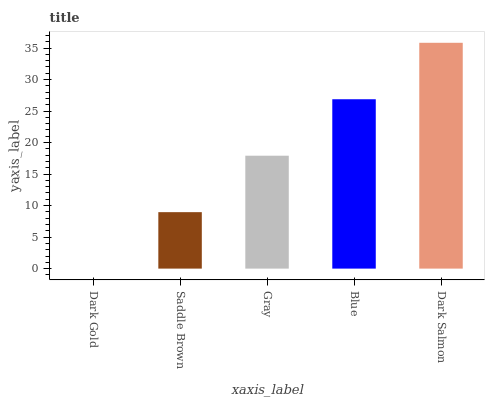Is Dark Gold the minimum?
Answer yes or no. Yes. Is Dark Salmon the maximum?
Answer yes or no. Yes. Is Saddle Brown the minimum?
Answer yes or no. No. Is Saddle Brown the maximum?
Answer yes or no. No. Is Saddle Brown greater than Dark Gold?
Answer yes or no. Yes. Is Dark Gold less than Saddle Brown?
Answer yes or no. Yes. Is Dark Gold greater than Saddle Brown?
Answer yes or no. No. Is Saddle Brown less than Dark Gold?
Answer yes or no. No. Is Gray the high median?
Answer yes or no. Yes. Is Gray the low median?
Answer yes or no. Yes. Is Dark Salmon the high median?
Answer yes or no. No. Is Dark Gold the low median?
Answer yes or no. No. 